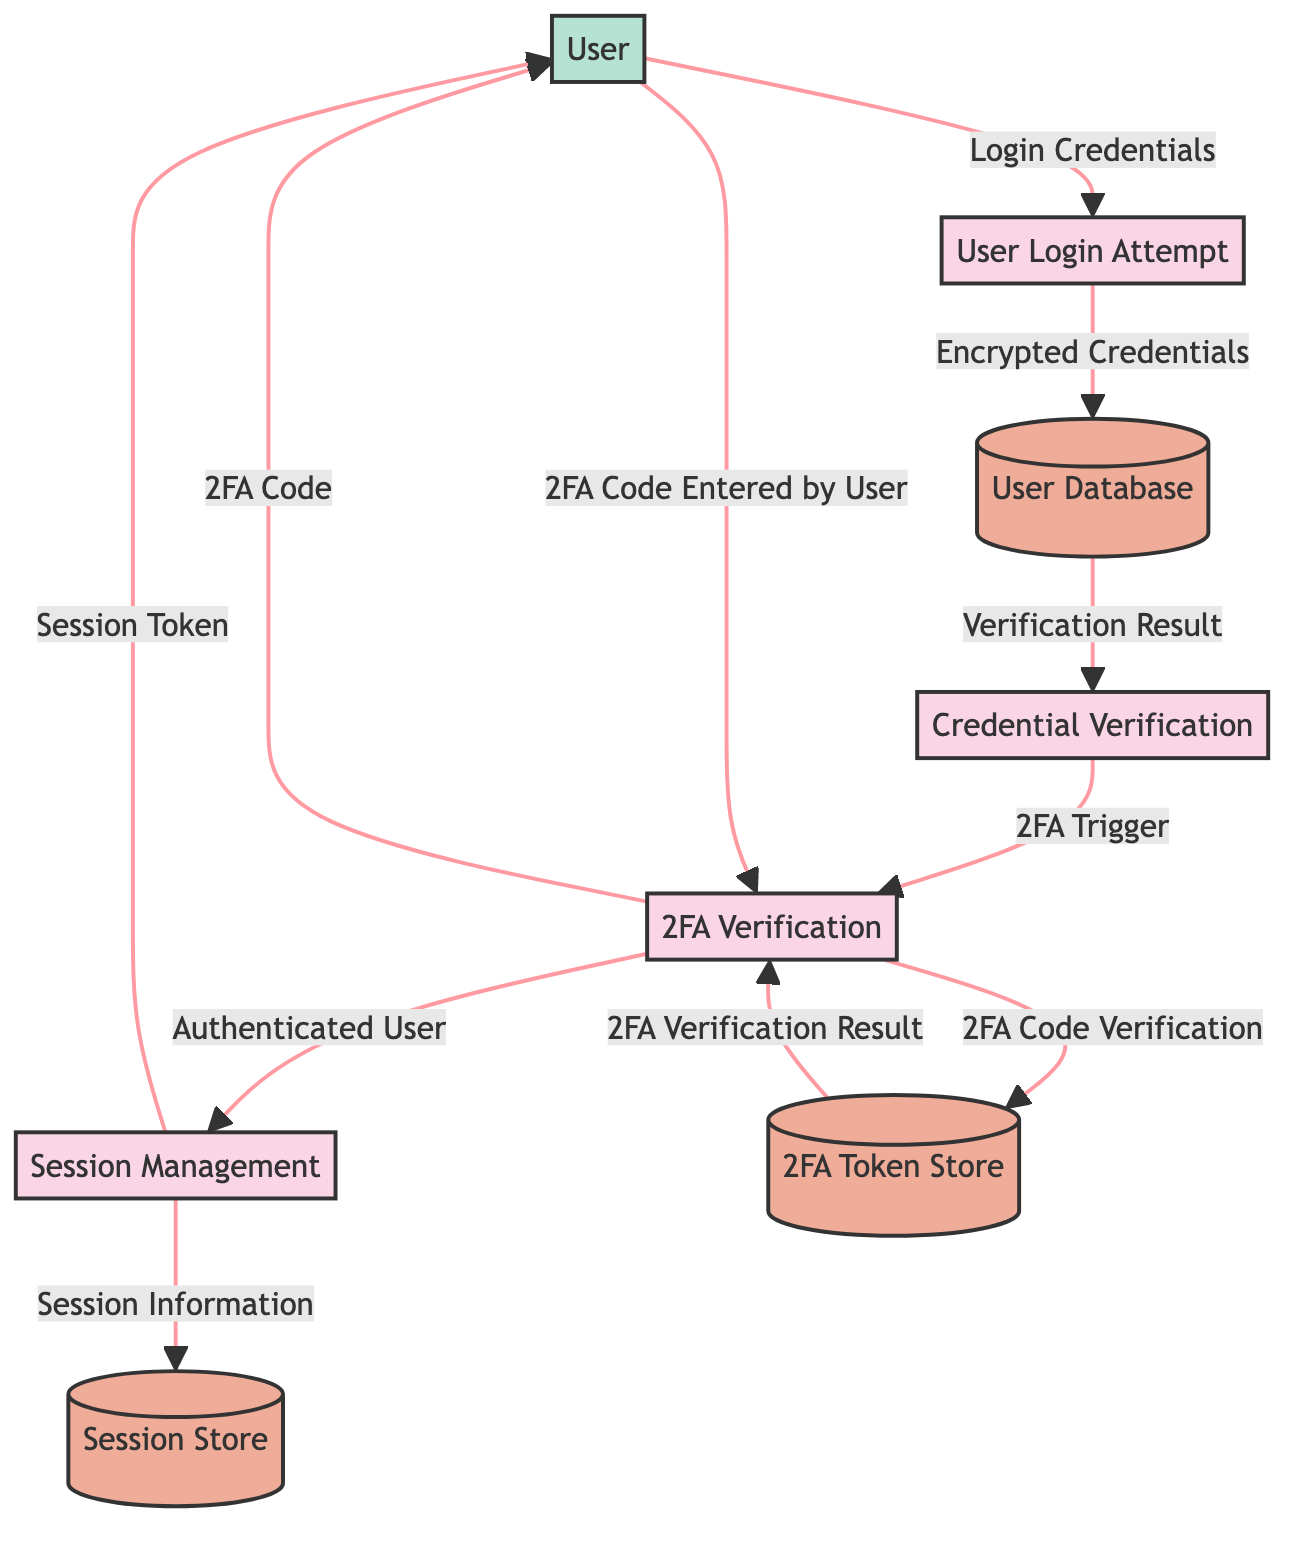What is the name of the first process in the diagram? The first process is labeled as "User Login Attempt," which is indicated within the diagram as the initial action taken in the authentication workflow.
Answer: User Login Attempt How many data flows are present in the diagram? Counting all the arrows connecting the processes, data stores, and external entities in the diagram, there are eleven data flows in total.
Answer: Eleven What is the role of the User Database? The User Database is described as the data store containing user credentials and profile information in encrypted form, indicating its critical role in storing sensitive user data that is used during authentication.
Answer: Data store containing user credentials and profile information in encrypted form Which process sends the 2FA code to the user? The 2FA Verification process (P3) sends the 2FA code to the user (E1) once it is triggered, indicating that this process is responsible for communication with the user to complete the authentication.
Answer: 2FA Verification What type of data does the Session Management process send back to the user? The Session Management process provides the user with a Session Token upon successful authentication, which is essential for the user to maintain an active session on the e-commerce platform.
Answer: Session Token What is the relationship between Credential Verification and 2FA Verification? Credential Verification (P2) directly leads into the 2FA Verification (P3), meaning it triggers the next process if the user's credentials are verified successfully, indicating a sequential dependency in the authentication process.
Answer: 2FA Trigger How many external entities are represented in the diagram? The diagram features one external entity, which represents the user interacting with the e-commerce platform as part of the authentication workflow.
Answer: One Which data store is used to manage active user sessions? The Session Store is used specifically for managing active user sessions and session tokens, indicating its function in maintaining the user's logged-in state during their interaction with the platform.
Answer: Session Store What happens if the 2FA code is entered correctly by the user? If the 2FA code is entered correctly by the user (E1), the process will flow to the Session Management process (P4), indicating that the user is authenticated and ready to have a session created.
Answer: Flow to Session Management What type of data is stored in the 2FA Token Store? The 2FA Token Store holds temporary tokens or codes that are used for two-factor authentication, indicating that it serves as a secure storage for validation during the 2FA process.
Answer: Temporary tokens or codes used in two-factor authentication 